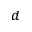<formula> <loc_0><loc_0><loc_500><loc_500>^ { d }</formula> 